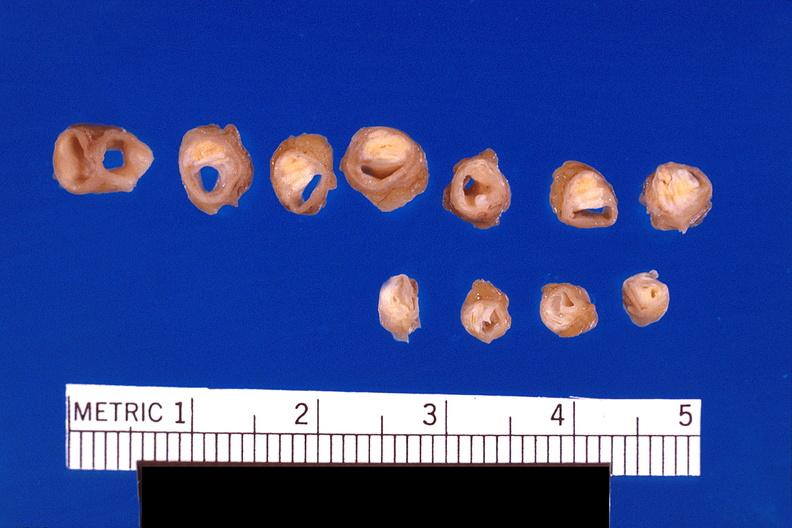s acid present?
Answer the question using a single word or phrase. No 